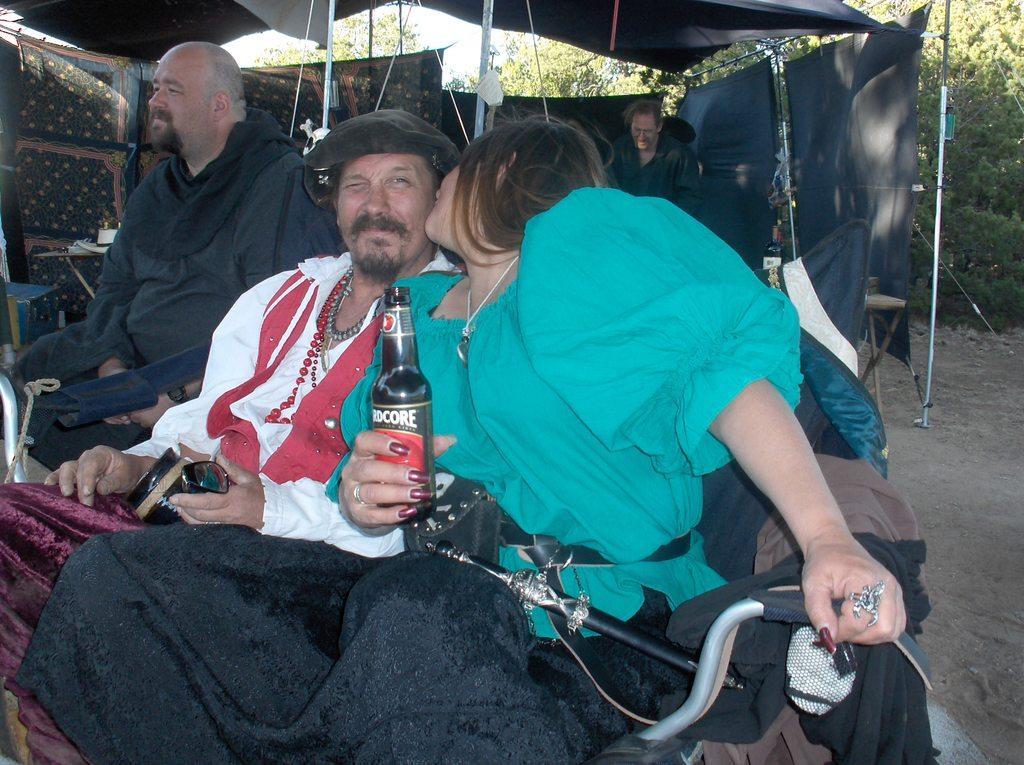Describe this image in one or two sentences. In this picture we can see three persons sitting on the chairs. This is bottle. And there is a tent. On the background we can see trees and this is sky. 